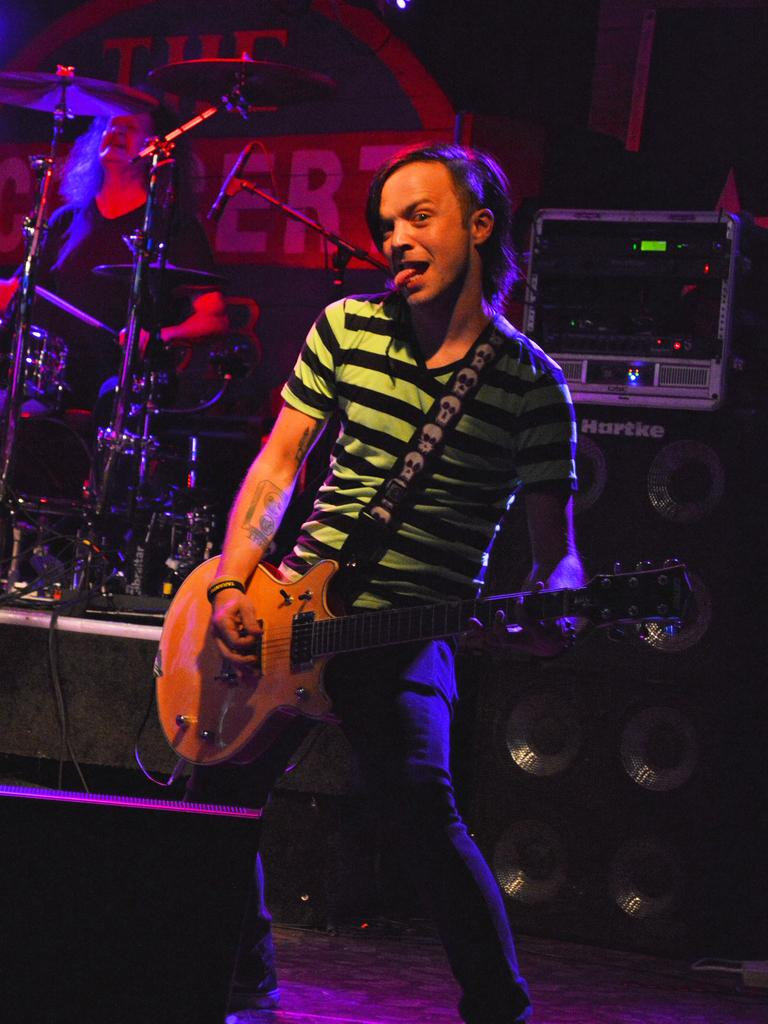What is the man in the image doing? The man is playing the guitar in the image. What is the man wearing in the image? The man is wearing a T-shirt in the image. What expression does the man have in the image? The man is sticking out his tongue and has a different face look in the image. What object is present in the image that is related to music? There is a microphone in the image. Can you tell me how many pencils are being used to play the game in the image? There is no game or pencils present in the image; it features a man playing the guitar and a microphone. 